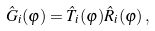<formula> <loc_0><loc_0><loc_500><loc_500>\hat { G } _ { i } ( \varphi ) = \hat { T } _ { i } ( \varphi ) \hat { R } _ { i } ( \varphi ) \, ,</formula> 